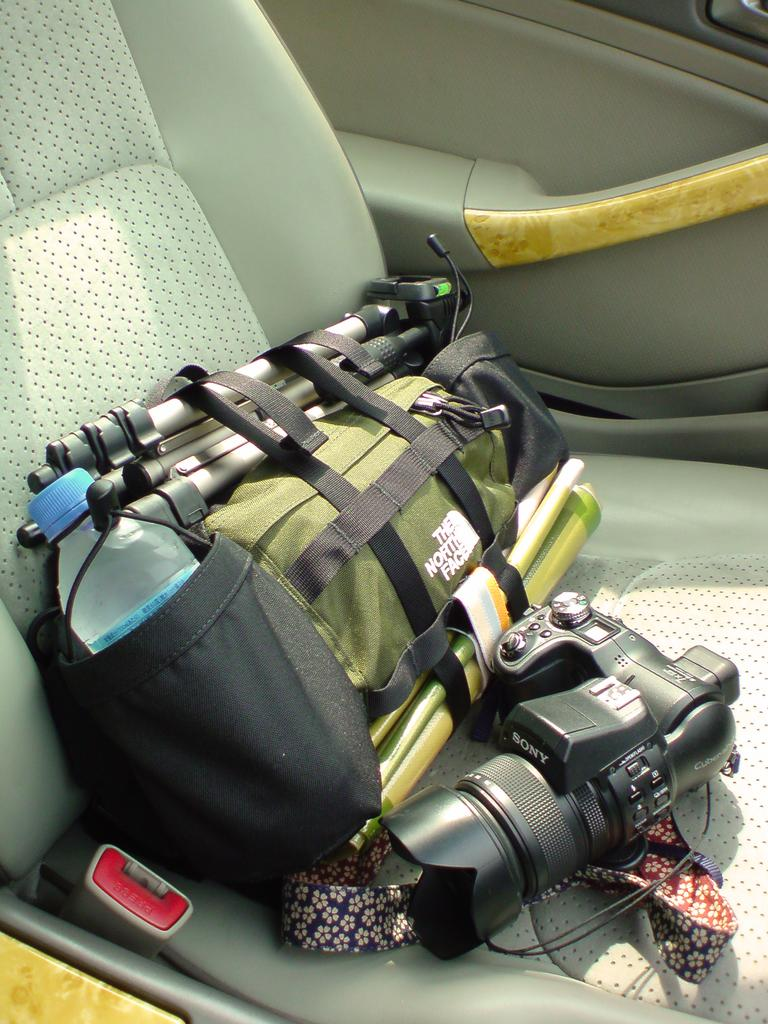What is the main object in the image? There is a digital camera in the image. What is used to support the camera in the image? There is a tripod stand in the image. What might be used to carry or store items in the image? There is a bag in the image. What can be seen in the background of the image? There is a vehicle door in the background of the image. What type of reward is being offered to the person in the image? There is no person or reward present in the image; it only features a digital camera, tripod stand, bag, and vehicle door. 